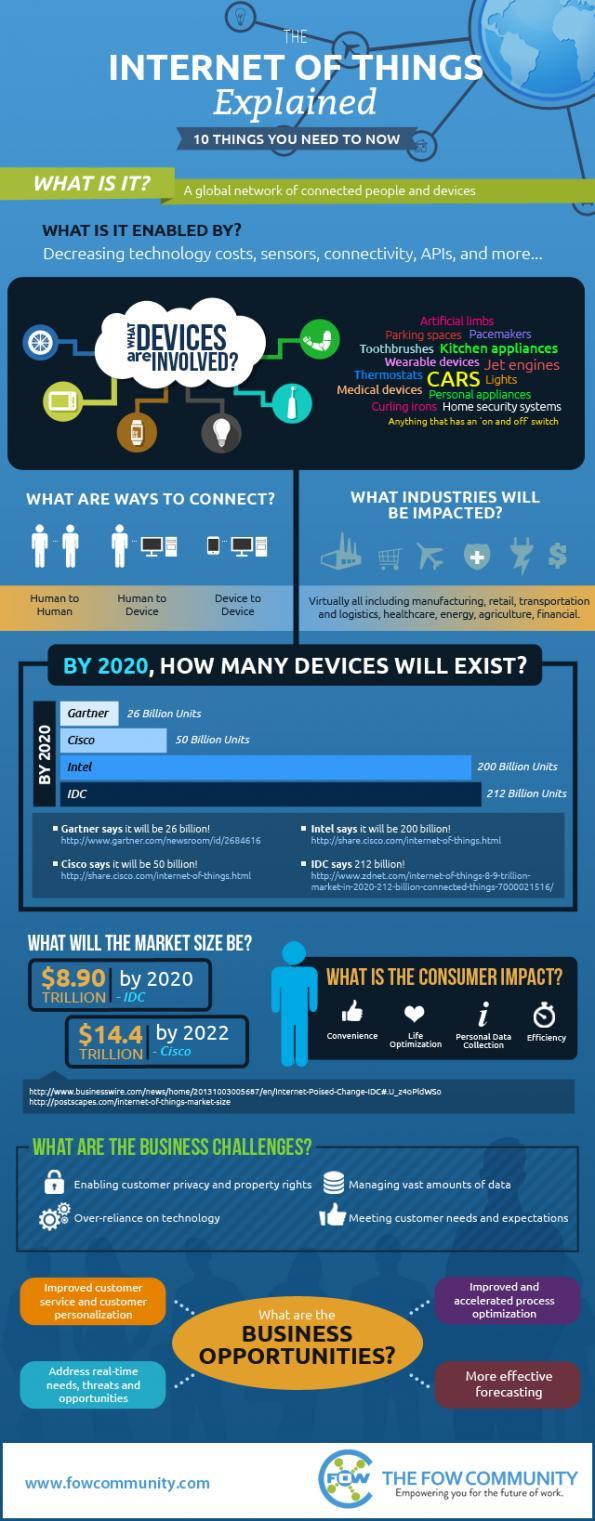How many billion units of devices of cisco and Gartner are expected to exist by 2020 respectively?
Answer the question with a short phrase. 50 billion units, 26 billion units What is the third challenge given in the list of business challenges? over-reliance on technology Which company will have more devices by 2020 - cisco or Gartner? cisco by 2020, which company will less more devices? gartner What is the second point given in the list of consumer impacts? life optimization by 2020, which company will have more devices? IDC How many billion units of devices of Intel and IDC would exist by 2020 respectively? 200 billion units, 212 billion units, What is the difference between the number of devices that would exist at intel and IDC in billion units, by 2020 12 What are the different type of connections of internet of things technology? human to human, device to human, device to device Which company will have more devices by 2020 - intel or IDC? IDC 